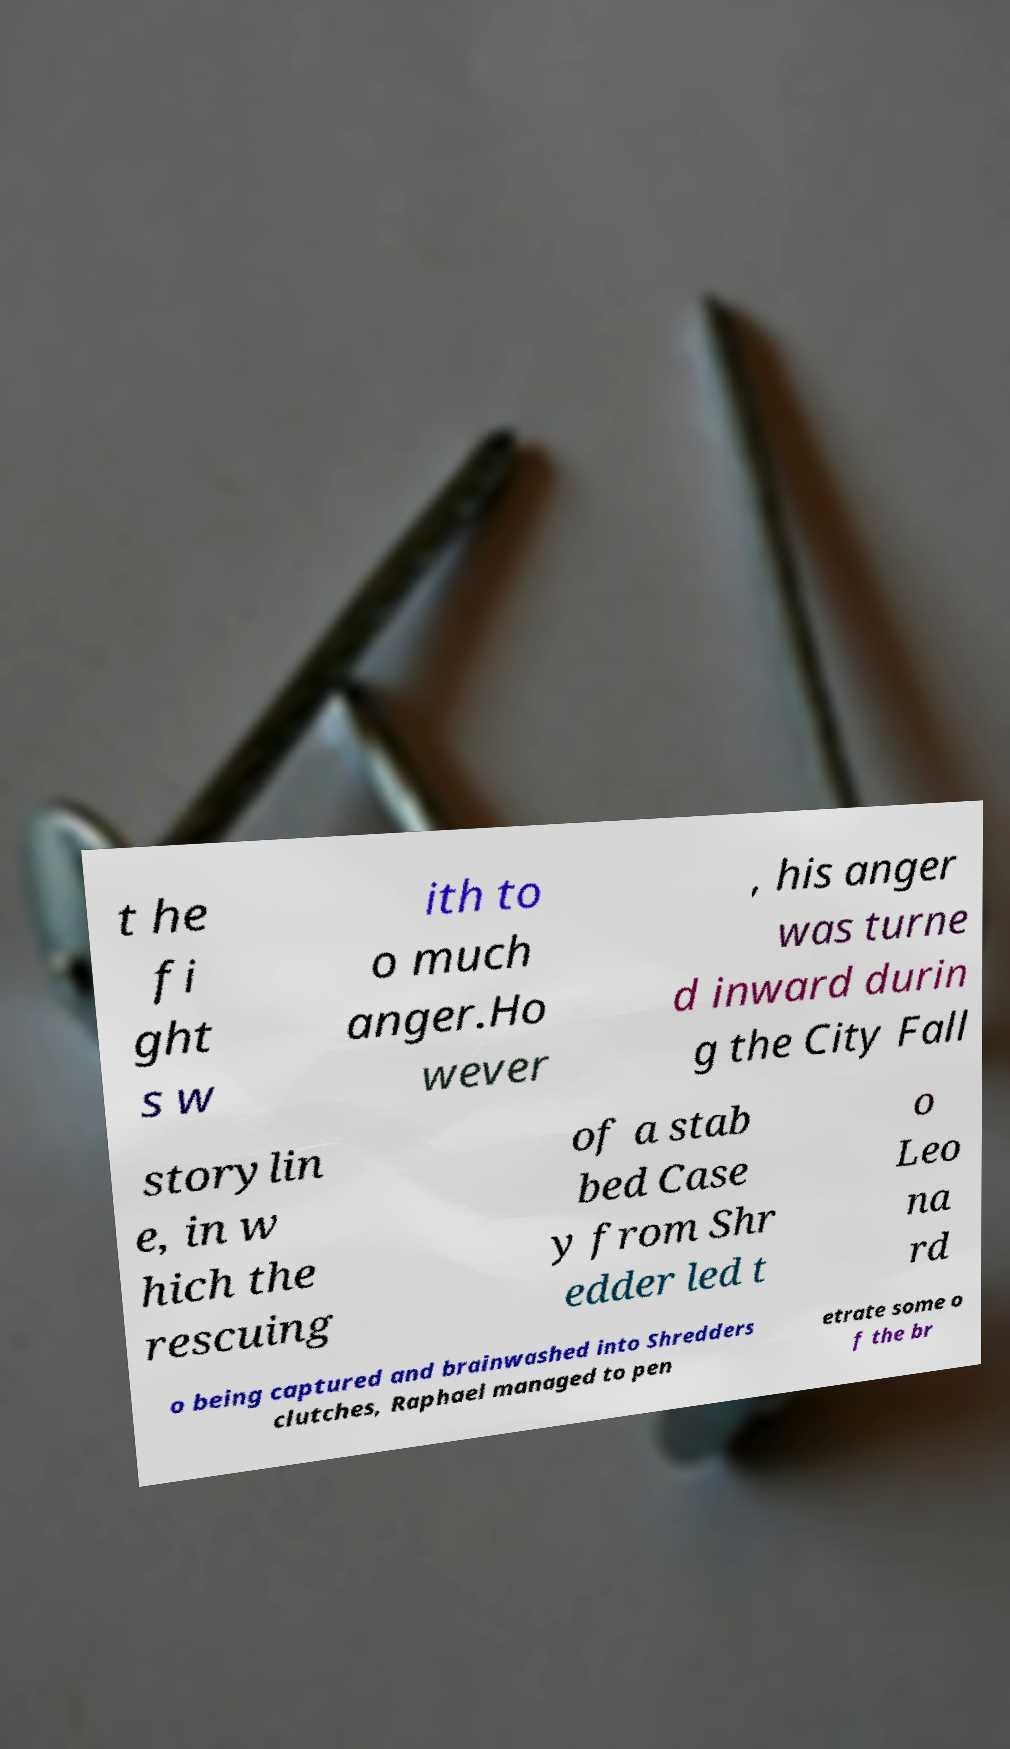Can you read and provide the text displayed in the image?This photo seems to have some interesting text. Can you extract and type it out for me? t he fi ght s w ith to o much anger.Ho wever , his anger was turne d inward durin g the City Fall storylin e, in w hich the rescuing of a stab bed Case y from Shr edder led t o Leo na rd o being captured and brainwashed into Shredders clutches, Raphael managed to pen etrate some o f the br 